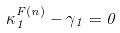Convert formula to latex. <formula><loc_0><loc_0><loc_500><loc_500>\kappa _ { 1 } ^ { F ( n ) } - \gamma _ { 1 } = 0</formula> 